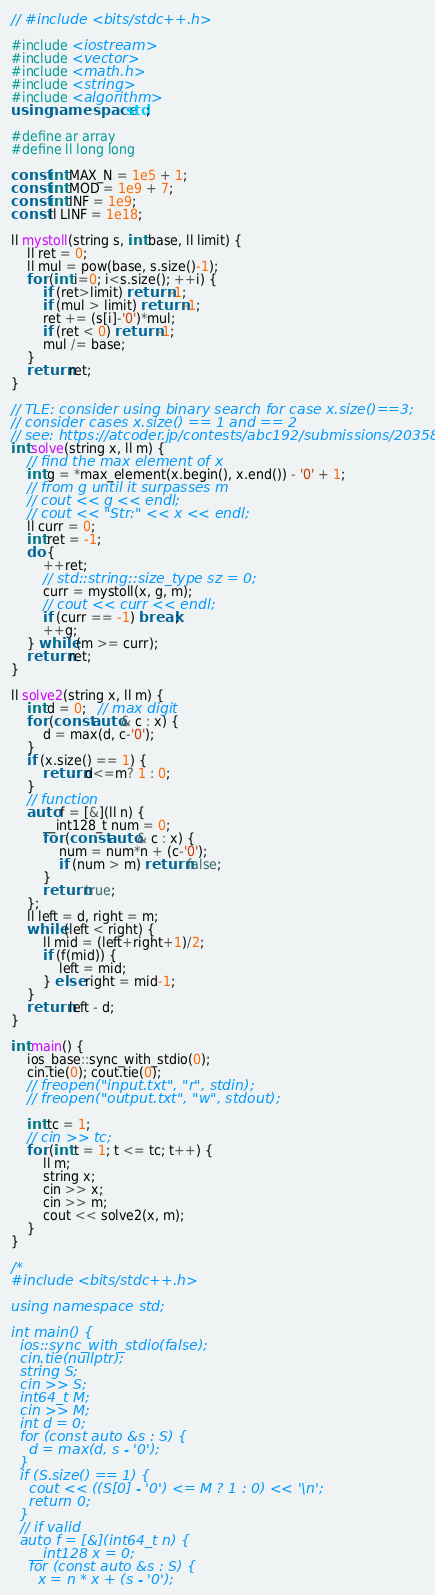Convert code to text. <code><loc_0><loc_0><loc_500><loc_500><_C++_>// #include <bits/stdc++.h>

#include <iostream>
#include <vector>
#include <math.h>
#include <string>
#include <algorithm>
using namespace std;

#define ar array
#define ll long long

const int MAX_N = 1e5 + 1;
const int MOD = 1e9 + 7;
const int INF = 1e9;
const ll LINF = 1e18;

ll mystoll(string s, int base, ll limit) {
    ll ret = 0;
    ll mul = pow(base, s.size()-1);
    for (int i=0; i<s.size(); ++i) {
        if (ret>limit) return -1; 
        if (mul > limit) return -1;
        ret += (s[i]-'0')*mul;
        if (ret < 0) return -1;
        mul /= base;
    }
    return ret; 
}

// TLE: consider using binary search for case x.size()==3;
// consider cases x.size() == 1 and == 2 
// see: https://atcoder.jp/contests/abc192/submissions/20358286 
int solve(string x, ll m) {
    // find the max element of x 
    int g = *max_element(x.begin(), x.end()) - '0' + 1;
    // from g until it surpasses m
    // cout << g << endl;
    // cout << "Str:" << x << endl;
    ll curr = 0; 
    int ret = -1;
    do {
        ++ret;
        // std::string::size_type sz = 0;
        curr = mystoll(x, g, m);
        // cout << curr << endl;
        if (curr == -1) break; 
        ++g;
    } while (m >= curr);
    return ret;
}

ll solve2(string x, ll m) {
    int d = 0;   // max digit 
    for (const auto& c : x) {
        d = max(d, c-'0');
    }
    if (x.size() == 1) {
        return d<=m? 1 : 0;
    }
    // function 
    auto f = [&](ll n) {
        __int128_t num = 0;
        for (const auto& c : x) {
            num = num*n + (c-'0');
            if (num > m) return false;
        }
        return true; 
    };
    ll left = d, right = m;
    while (left < right) {
        ll mid = (left+right+1)/2;
        if (f(mid)) {
            left = mid;
        } else right = mid-1; 
    }
    return left - d; 
}

int main() {
    ios_base::sync_with_stdio(0);
    cin.tie(0); cout.tie(0);
    // freopen("input.txt", "r", stdin);
    // freopen("output.txt", "w", stdout);

    int tc = 1;
    // cin >> tc;
    for (int t = 1; t <= tc; t++) {
        ll m;
        string x;
        cin >> x; 
        cin >> m;
        cout << solve2(x, m);
    }
}

/*
#include <bits/stdc++.h>
 
using namespace std;
 
int main() {
  ios::sync_with_stdio(false);
  cin.tie(nullptr);
  string S;
  cin >> S;
  int64_t M;
  cin >> M;
  int d = 0;
  for (const auto &s : S) {
    d = max(d, s - '0');
  }
  if (S.size() == 1) {
    cout << ((S[0] - '0') <= M ? 1 : 0) << '\n';
    return 0;
  }
  // if valid 
  auto f = [&](int64_t n) {
    __int128 x = 0;
    for (const auto &s : S) {
      x = n * x + (s - '0');</code> 